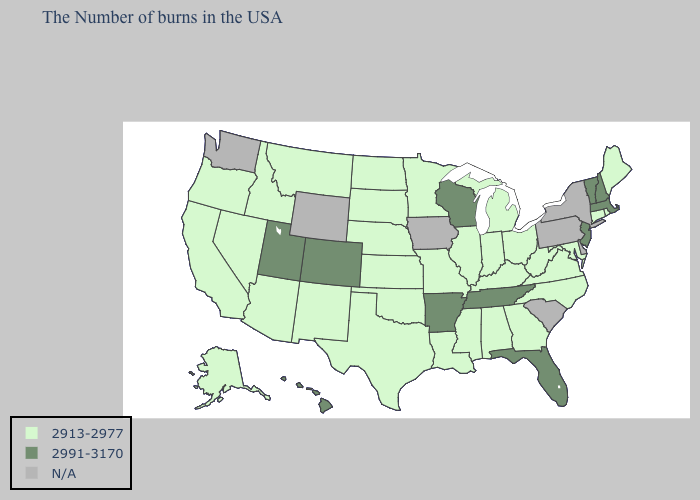Among the states that border Delaware , does New Jersey have the highest value?
Short answer required. Yes. What is the lowest value in states that border Rhode Island?
Short answer required. 2913-2977. Among the states that border Texas , which have the lowest value?
Short answer required. Louisiana, Oklahoma, New Mexico. What is the value of Iowa?
Keep it brief. N/A. What is the lowest value in the South?
Short answer required. 2913-2977. What is the value of California?
Be succinct. 2913-2977. Name the states that have a value in the range 2991-3170?
Quick response, please. Massachusetts, New Hampshire, Vermont, New Jersey, Florida, Tennessee, Wisconsin, Arkansas, Colorado, Utah, Hawaii. Does Arkansas have the highest value in the USA?
Quick response, please. Yes. What is the highest value in the MidWest ?
Short answer required. 2991-3170. Name the states that have a value in the range 2991-3170?
Concise answer only. Massachusetts, New Hampshire, Vermont, New Jersey, Florida, Tennessee, Wisconsin, Arkansas, Colorado, Utah, Hawaii. Name the states that have a value in the range 2913-2977?
Write a very short answer. Maine, Rhode Island, Connecticut, Maryland, Virginia, North Carolina, West Virginia, Ohio, Georgia, Michigan, Kentucky, Indiana, Alabama, Illinois, Mississippi, Louisiana, Missouri, Minnesota, Kansas, Nebraska, Oklahoma, Texas, South Dakota, North Dakota, New Mexico, Montana, Arizona, Idaho, Nevada, California, Oregon, Alaska. Which states have the lowest value in the USA?
Give a very brief answer. Maine, Rhode Island, Connecticut, Maryland, Virginia, North Carolina, West Virginia, Ohio, Georgia, Michigan, Kentucky, Indiana, Alabama, Illinois, Mississippi, Louisiana, Missouri, Minnesota, Kansas, Nebraska, Oklahoma, Texas, South Dakota, North Dakota, New Mexico, Montana, Arizona, Idaho, Nevada, California, Oregon, Alaska. Name the states that have a value in the range 2913-2977?
Give a very brief answer. Maine, Rhode Island, Connecticut, Maryland, Virginia, North Carolina, West Virginia, Ohio, Georgia, Michigan, Kentucky, Indiana, Alabama, Illinois, Mississippi, Louisiana, Missouri, Minnesota, Kansas, Nebraska, Oklahoma, Texas, South Dakota, North Dakota, New Mexico, Montana, Arizona, Idaho, Nevada, California, Oregon, Alaska. How many symbols are there in the legend?
Concise answer only. 3. 